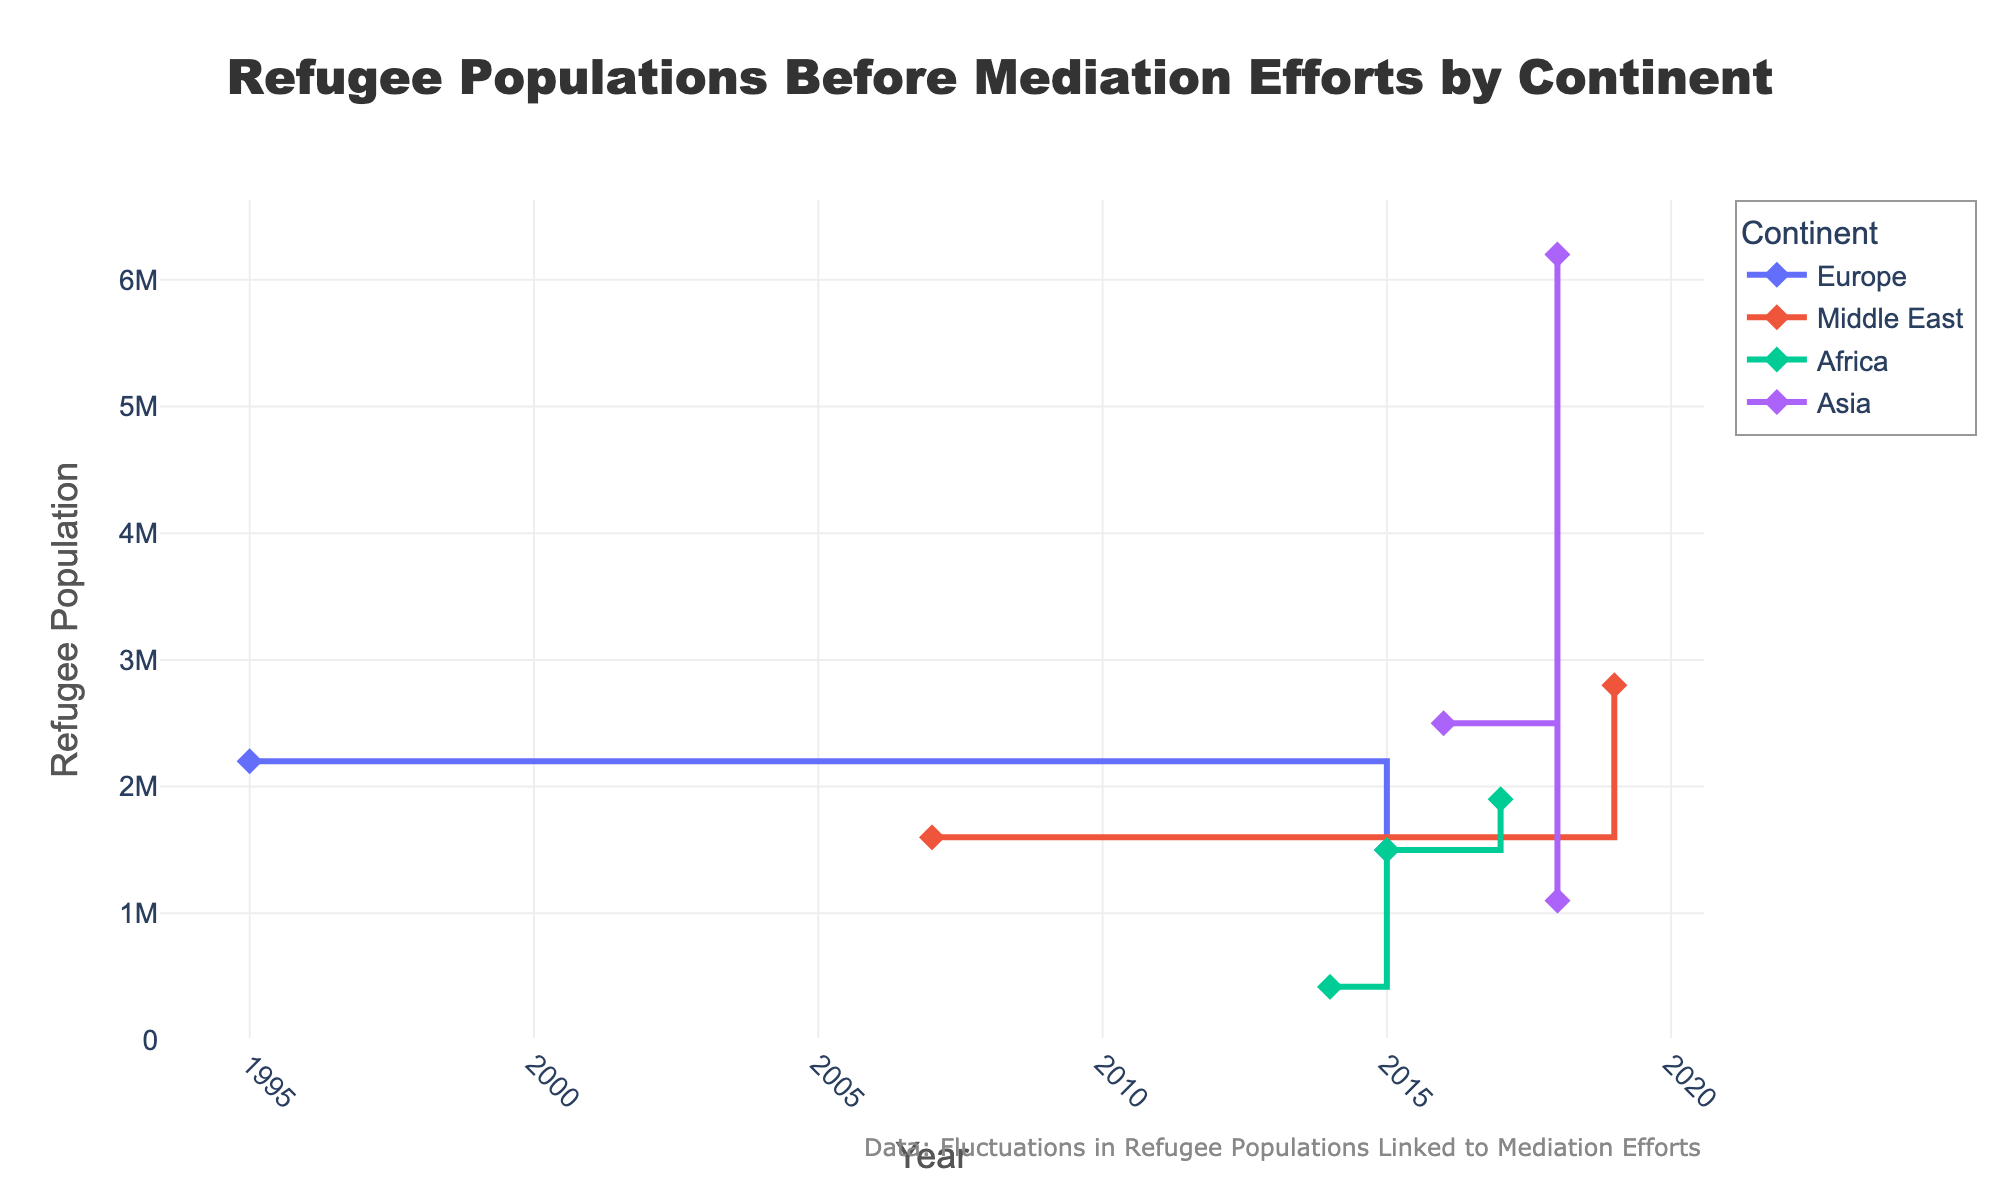What's the title of the figure? The title is typically found at the top of the figure and summarizes what the figure is about.
Answer: Refugee Populations Before Mediation Efforts by Continent What is the y-axis representing? The y-axis represents the numerical values for refugee populations before mediation efforts, as indicated by the axis label.
Answer: Refugee Population Which continent has the data point with the highest refugee population before mediation efforts? Examine the data points on the stair plot and identify the highest point on the y-axis.
Answer: Asia How many continents are represented in the plot? Count the unique continent names listed in the legend of the plot.
Answer: 4 Between which years is the data spread? Look at the range of years on the x-axis to determine the entire span.
Answer: 1995 to 2019 Which continent shows a decrease in refugee populations for Bosnia and Herzegovina in 1995? Locate the 1995 data point for Bosnia and Herzegovina and identify the associated continent.
Answer: Europe Compare the refugee population before mediation efforts in South Sudan and Yemen. Which one had a higher population? Locate the data points for South Sudan and Yemen and compare their values on the y-axis.
Answer: Yemen Did the mediation by Germany result in a decrease or increase in refugee population in Ukraine? Check the direction of change for the Ukraine data point. As per the dataset, it shows a reduction.
Answer: Decrease What is the median year of the recorded data? To find the median, arrange all the years in ascending order and select the middle value. The years are 1995, 2007, 2014, 2015, 2015, 2016, 2017, 2018, 2018, 2019; thus, the median is between the 5th and 6th value (2015+2016)/2.
Answer: 2015.5 What trend do you observe in the data from 2015? Look at the continuity and patterns from 2015 onwards on the x-axis corresponding with the y-axis trends.
Answer: General decrease in refugee populations 